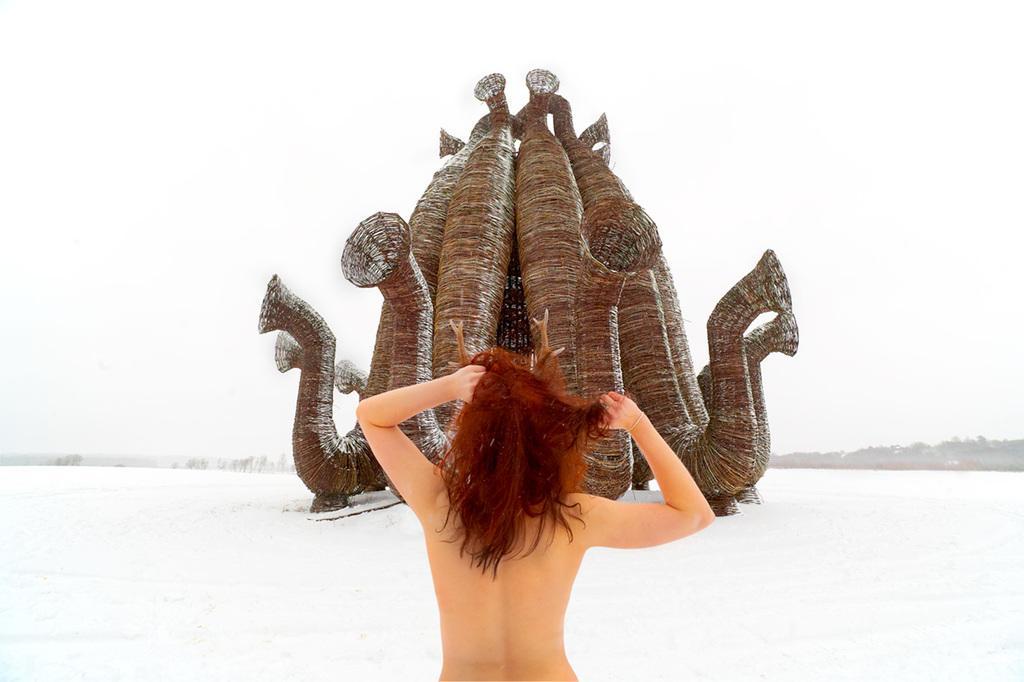How would you summarize this image in a sentence or two? In this picture I can observe a woman in the middle of the picture. In front of the woman there is a sculpture on the land. I can observe some snow on the land. In the background I can observe sky. 